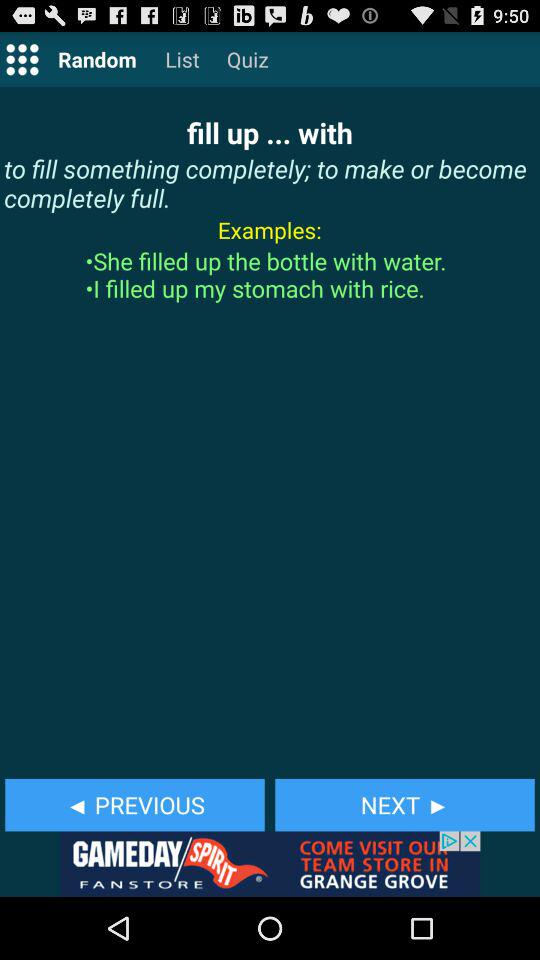How many examples are there in the examples section?
Answer the question using a single word or phrase. 2 